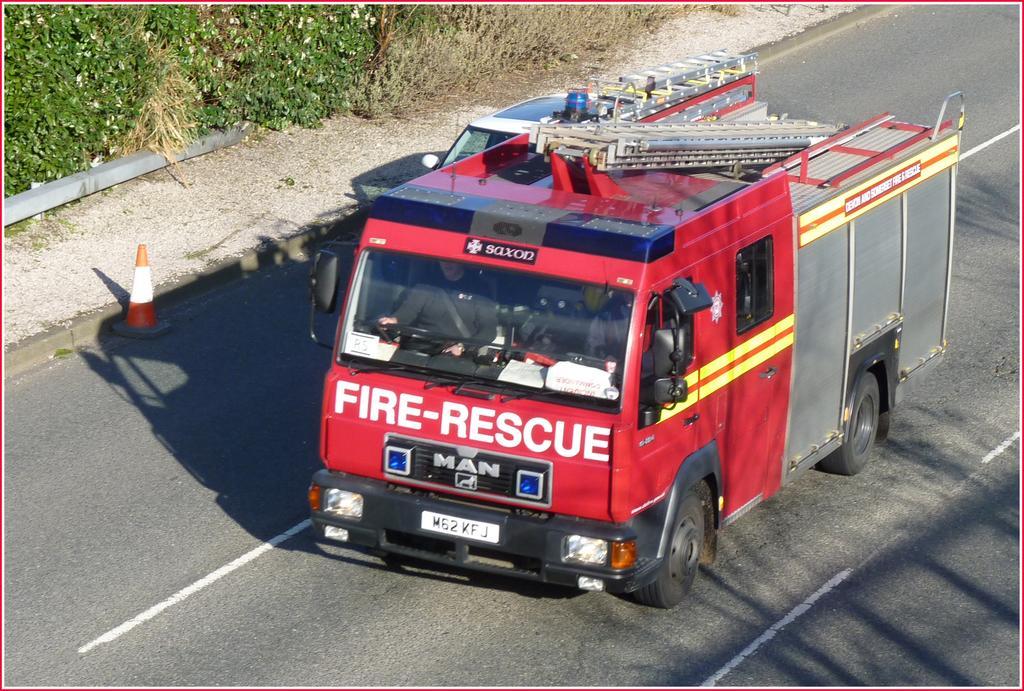Could you give a brief overview of what you see in this image? In this image I can see a vehicle and car on the road. At the top of the image there are some plants. 